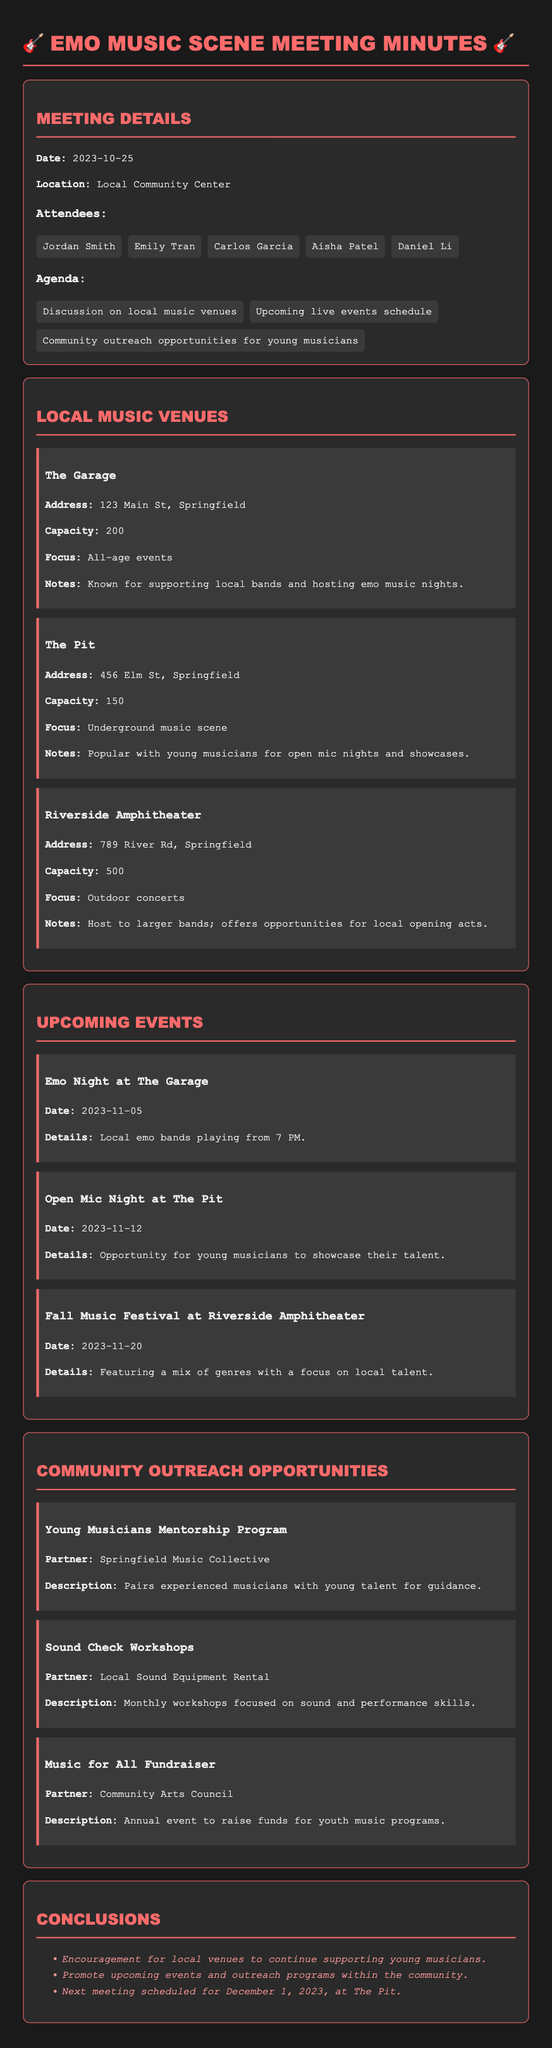What is the date of the meeting? The date of the meeting is specified in the document as October 25, 2023.
Answer: October 25, 2023 What venue is known for hosting emo music nights? The venue that is known for hosting emo music nights is mentioned in the notes section.
Answer: The Garage What is the capacity of The Pit? The capacity for The Pit is clearly stated in the information provided.
Answer: 150 When is the Open Mic Night at The Pit? The date for the Open Mic Night is given explicitly in the upcoming events section.
Answer: November 12 What is the main focus of the Young Musicians Mentorship Program? The description of the program indicates its main purpose and focus.
Answer: Guidance What event features a mix of genres with a focus on local talent? The document describes this event, clearly stating its features.
Answer: Fall Music Festival Who is the partner for the Sound Check Workshops? The partner for these workshops is listed in the outreach section, indicating the involvement of a specific organization.
Answer: Local Sound Equipment Rental How many attendees were present at the meeting? The number of attendees can be counted from the list in the document.
Answer: 5 What is the next meeting's scheduled date? The document concludes with the date for the next meeting, making it easy to find.
Answer: December 1, 2023 